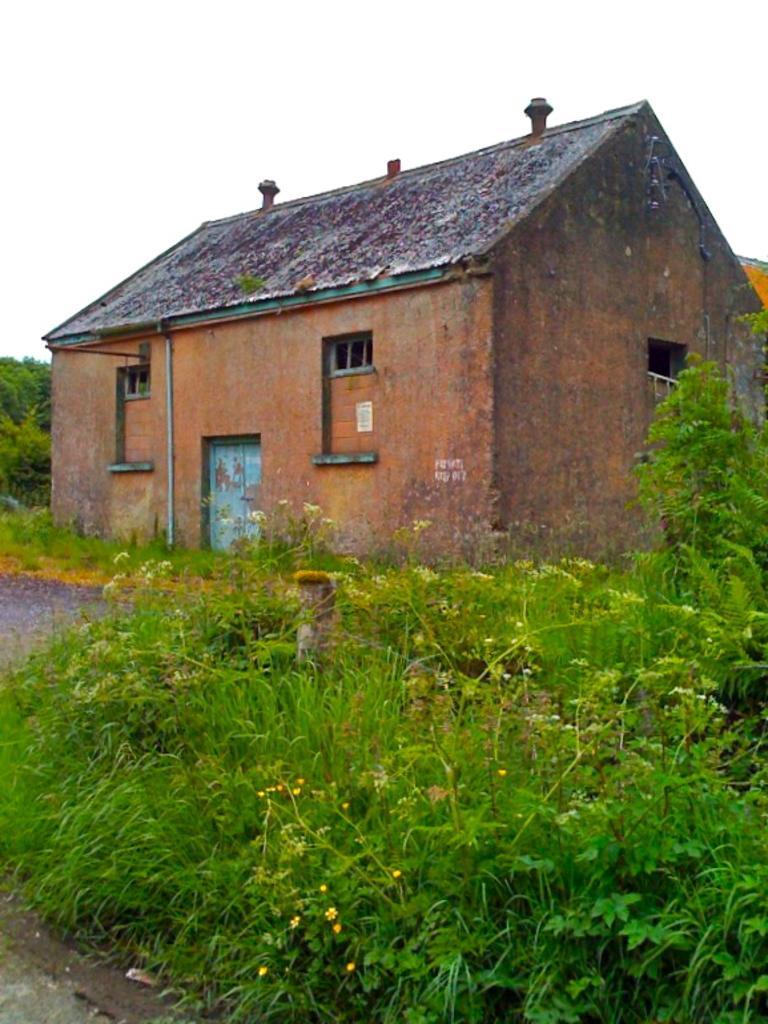Can you describe this image briefly? in this picture there is a house in the center of the image and there is a door on the left side of the image, there are plants on the right and left side of the image. 